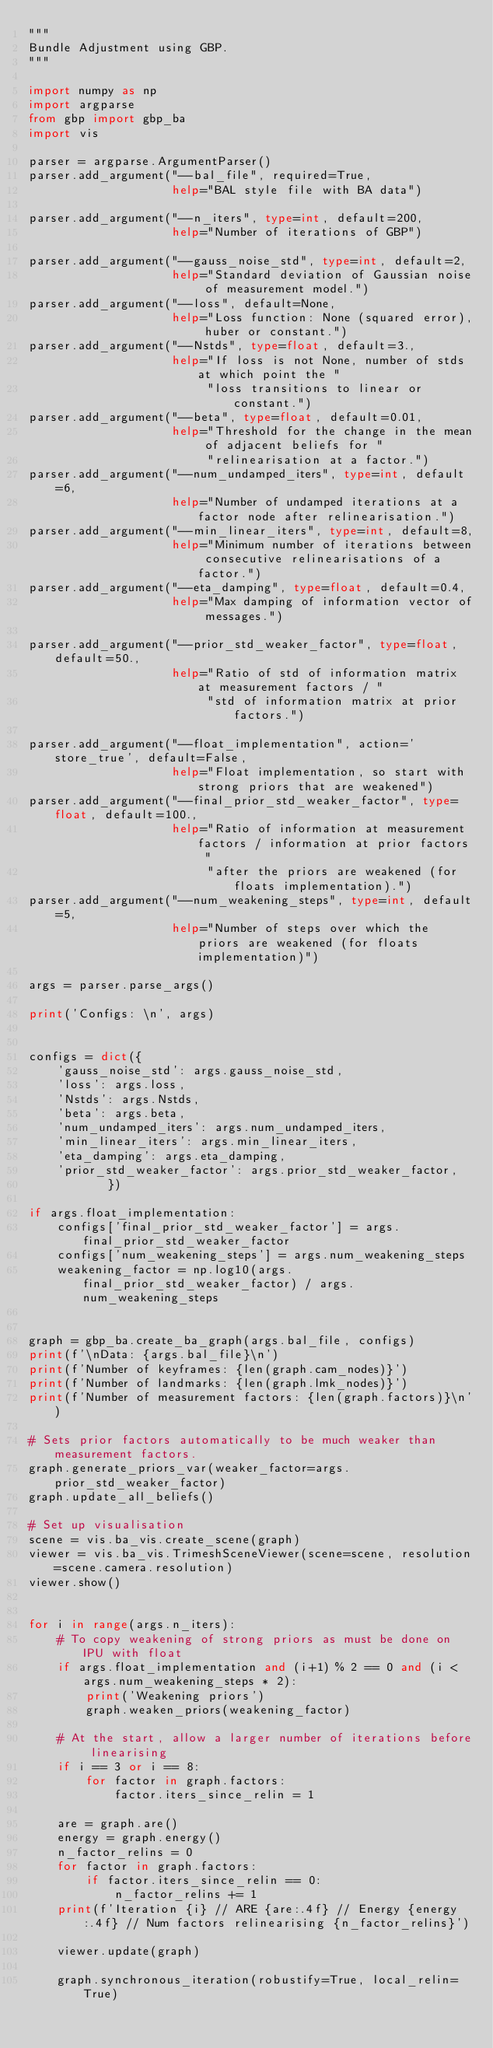Convert code to text. <code><loc_0><loc_0><loc_500><loc_500><_Python_>"""
Bundle Adjustment using GBP.
"""

import numpy as np
import argparse
from gbp import gbp_ba
import vis

parser = argparse.ArgumentParser()
parser.add_argument("--bal_file", required=True,
                    help="BAL style file with BA data")

parser.add_argument("--n_iters", type=int, default=200,
                    help="Number of iterations of GBP")

parser.add_argument("--gauss_noise_std", type=int, default=2,
                    help="Standard deviation of Gaussian noise of measurement model.")
parser.add_argument("--loss", default=None,
                    help="Loss function: None (squared error), huber or constant.")
parser.add_argument("--Nstds", type=float, default=3.,
                    help="If loss is not None, number of stds at which point the "
                         "loss transitions to linear or constant.")
parser.add_argument("--beta", type=float, default=0.01,
                    help="Threshold for the change in the mean of adjacent beliefs for "
                         "relinearisation at a factor.")
parser.add_argument("--num_undamped_iters", type=int, default=6,
                    help="Number of undamped iterations at a factor node after relinearisation.")
parser.add_argument("--min_linear_iters", type=int, default=8,
                    help="Minimum number of iterations between consecutive relinearisations of a factor.")
parser.add_argument("--eta_damping", type=float, default=0.4,
                    help="Max damping of information vector of messages.")

parser.add_argument("--prior_std_weaker_factor", type=float, default=50.,
                    help="Ratio of std of information matrix at measurement factors / "
                         "std of information matrix at prior factors.")

parser.add_argument("--float_implementation", action='store_true', default=False,
                    help="Float implementation, so start with strong priors that are weakened")
parser.add_argument("--final_prior_std_weaker_factor", type=float, default=100.,
                    help="Ratio of information at measurement factors / information at prior factors "
                         "after the priors are weakened (for floats implementation).")
parser.add_argument("--num_weakening_steps", type=int, default=5,
                    help="Number of steps over which the priors are weakened (for floats implementation)")

args = parser.parse_args()

print('Configs: \n', args)


configs = dict({
    'gauss_noise_std': args.gauss_noise_std,
    'loss': args.loss,
    'Nstds': args.Nstds,
    'beta': args.beta,
    'num_undamped_iters': args.num_undamped_iters,
    'min_linear_iters': args.min_linear_iters,
    'eta_damping': args.eta_damping,
    'prior_std_weaker_factor': args.prior_std_weaker_factor,
           })

if args.float_implementation:
    configs['final_prior_std_weaker_factor'] = args.final_prior_std_weaker_factor
    configs['num_weakening_steps'] = args.num_weakening_steps
    weakening_factor = np.log10(args.final_prior_std_weaker_factor) / args.num_weakening_steps


graph = gbp_ba.create_ba_graph(args.bal_file, configs)
print(f'\nData: {args.bal_file}\n')
print(f'Number of keyframes: {len(graph.cam_nodes)}')
print(f'Number of landmarks: {len(graph.lmk_nodes)}')
print(f'Number of measurement factors: {len(graph.factors)}\n')

# Sets prior factors automatically to be much weaker than measurement factors.
graph.generate_priors_var(weaker_factor=args.prior_std_weaker_factor)
graph.update_all_beliefs()

# Set up visualisation
scene = vis.ba_vis.create_scene(graph)
viewer = vis.ba_vis.TrimeshSceneViewer(scene=scene, resolution=scene.camera.resolution)
viewer.show()


for i in range(args.n_iters):
    # To copy weakening of strong priors as must be done on IPU with float
    if args.float_implementation and (i+1) % 2 == 0 and (i < args.num_weakening_steps * 2):
        print('Weakening priors')
        graph.weaken_priors(weakening_factor)

    # At the start, allow a larger number of iterations before linearising
    if i == 3 or i == 8:
        for factor in graph.factors:
            factor.iters_since_relin = 1

    are = graph.are()
    energy = graph.energy()
    n_factor_relins = 0
    for factor in graph.factors:
        if factor.iters_since_relin == 0:
            n_factor_relins += 1
    print(f'Iteration {i} // ARE {are:.4f} // Energy {energy:.4f} // Num factors relinearising {n_factor_relins}')

    viewer.update(graph)

    graph.synchronous_iteration(robustify=True, local_relin=True)

</code> 